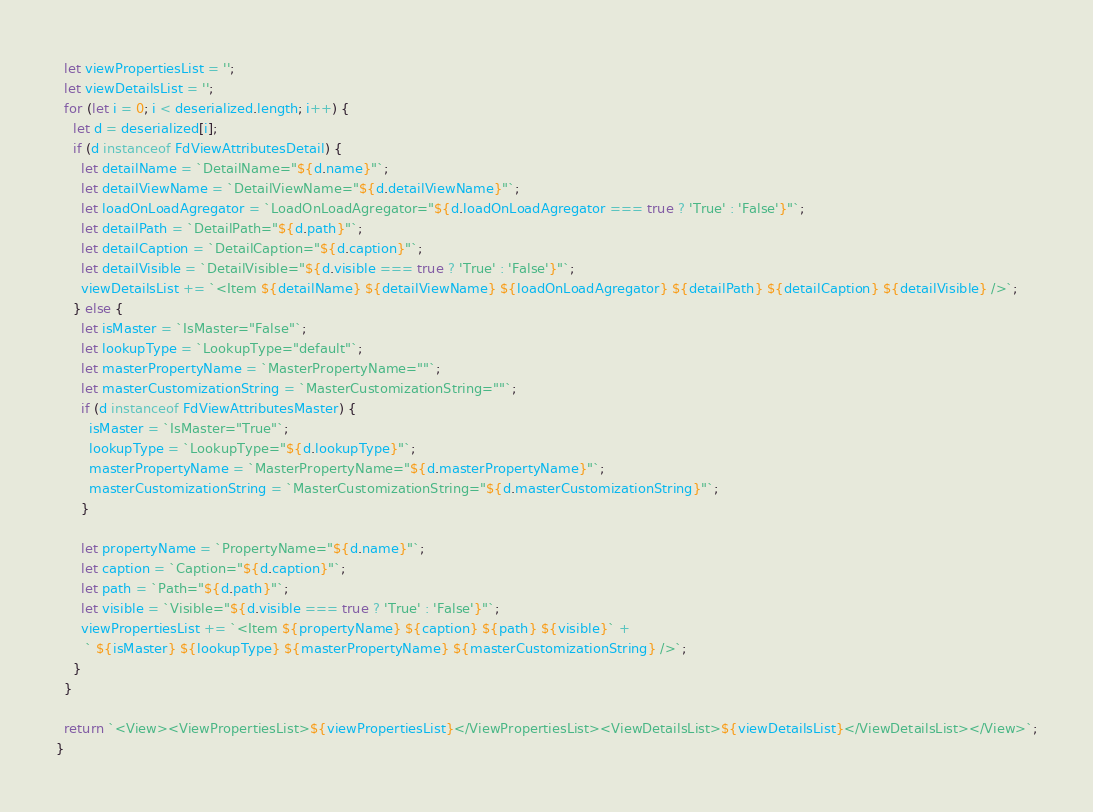Convert code to text. <code><loc_0><loc_0><loc_500><loc_500><_JavaScript_>  let viewPropertiesList = '';
  let viewDetailsList = '';
  for (let i = 0; i < deserialized.length; i++) {
    let d = deserialized[i];
    if (d instanceof FdViewAttributesDetail) {
      let detailName = `DetailName="${d.name}"`;
      let detailViewName = `DetailViewName="${d.detailViewName}"`;
      let loadOnLoadAgregator = `LoadOnLoadAgregator="${d.loadOnLoadAgregator === true ? 'True' : 'False'}"`;
      let detailPath = `DetailPath="${d.path}"`;
      let detailCaption = `DetailCaption="${d.caption}"`;
      let detailVisible = `DetailVisible="${d.visible === true ? 'True' : 'False'}"`;
      viewDetailsList += `<Item ${detailName} ${detailViewName} ${loadOnLoadAgregator} ${detailPath} ${detailCaption} ${detailVisible} />`;
    } else {
      let isMaster = `IsMaster="False"`;
      let lookupType = `LookupType="default"`;
      let masterPropertyName = `MasterPropertyName=""`;
      let masterCustomizationString = `MasterCustomizationString=""`;
      if (d instanceof FdViewAttributesMaster) {
        isMaster = `IsMaster="True"`;
        lookupType = `LookupType="${d.lookupType}"`;
        masterPropertyName = `MasterPropertyName="${d.masterPropertyName}"`;
        masterCustomizationString = `MasterCustomizationString="${d.masterCustomizationString}"`;
      }

      let propertyName = `PropertyName="${d.name}"`;
      let caption = `Caption="${d.caption}"`;
      let path = `Path="${d.path}"`;
      let visible = `Visible="${d.visible === true ? 'True' : 'False'}"`;
      viewPropertiesList += `<Item ${propertyName} ${caption} ${path} ${visible}` +
       ` ${isMaster} ${lookupType} ${masterPropertyName} ${masterCustomizationString} />`;
    }
  }

  return `<View><ViewPropertiesList>${viewPropertiesList}</ViewPropertiesList><ViewDetailsList>${viewDetailsList}</ViewDetailsList></View>`;
}
</code> 